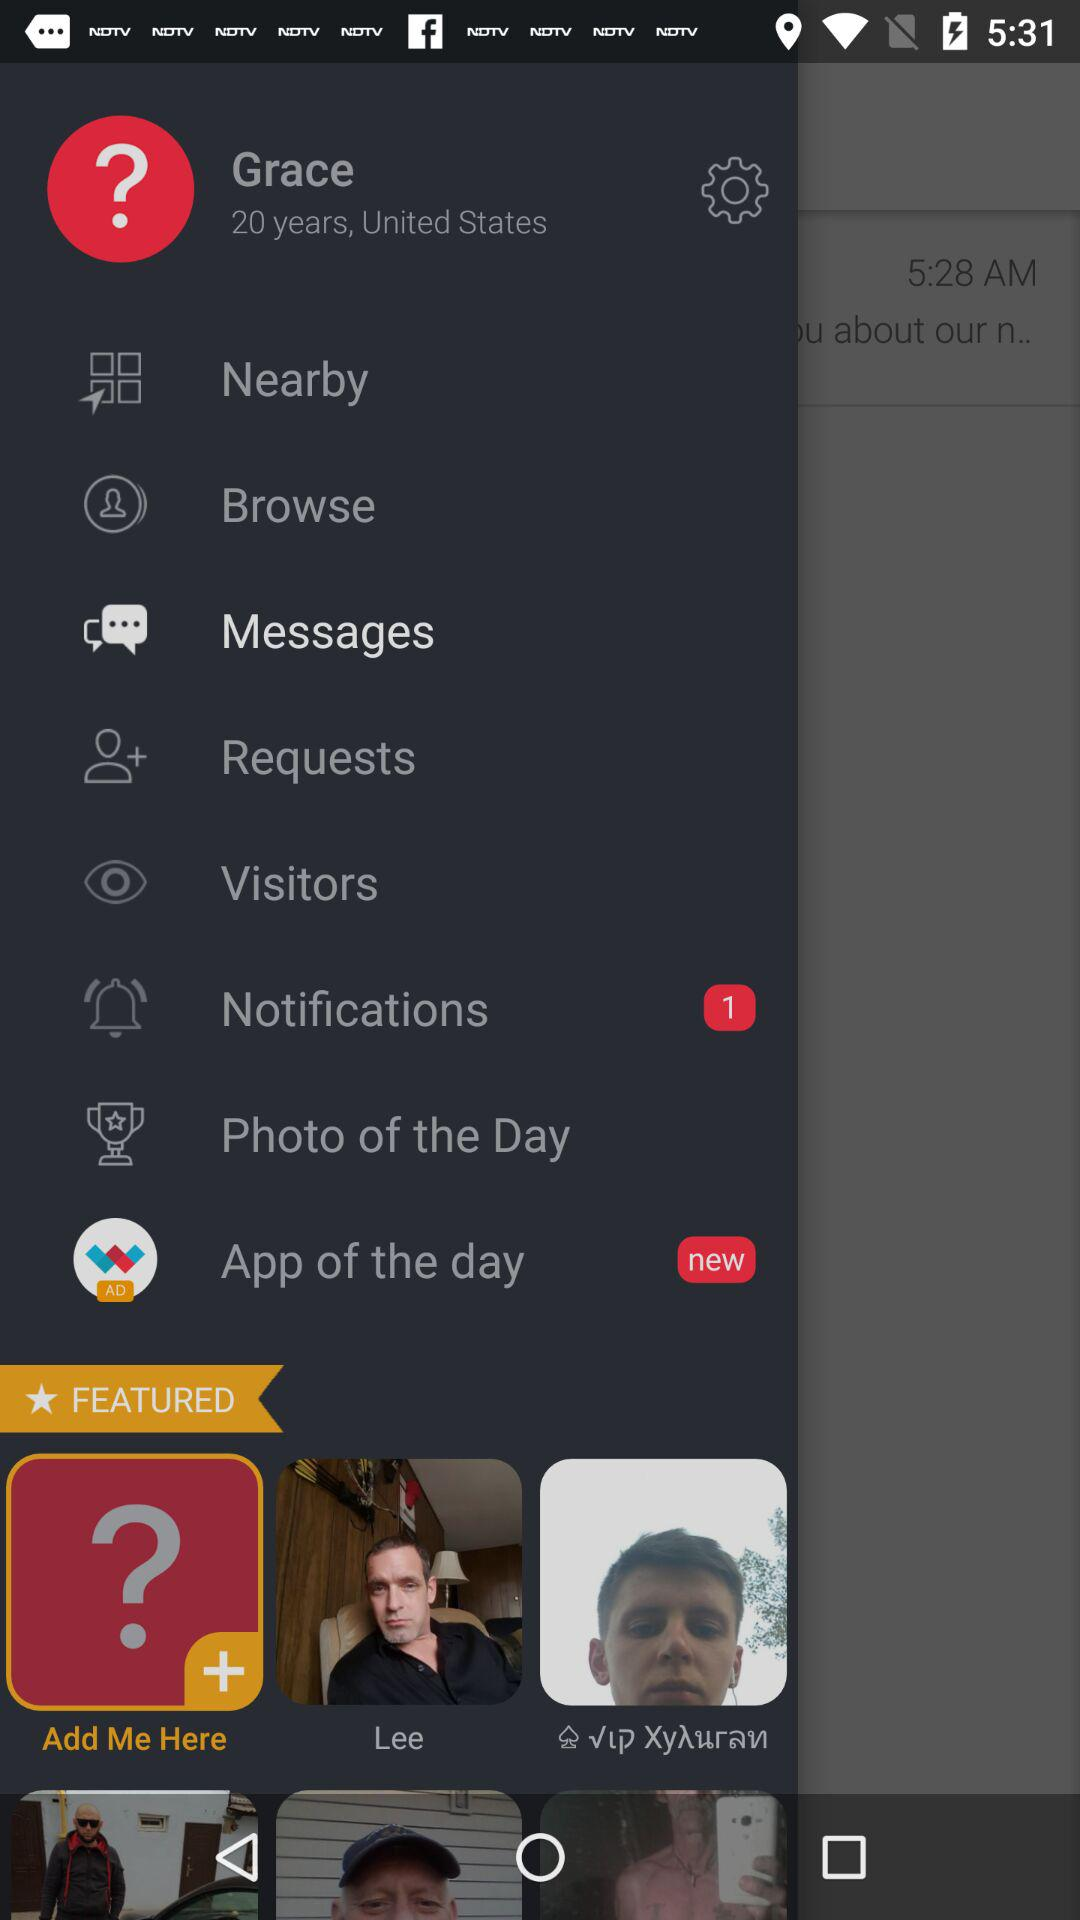What location is given? The given location is the United States. 